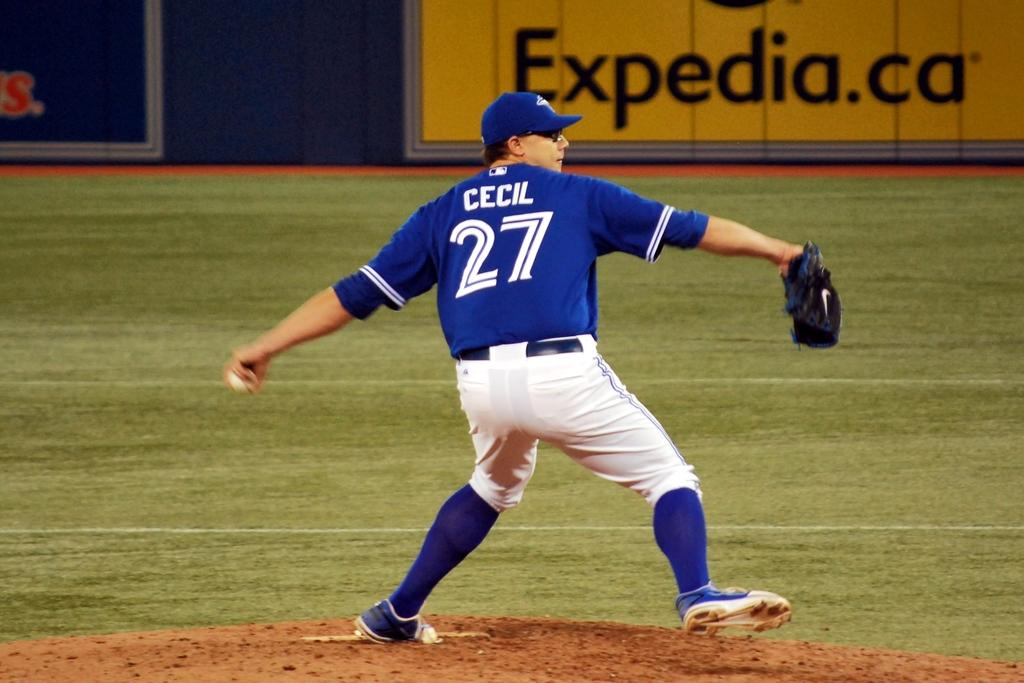<image>
Offer a succinct explanation of the picture presented. A baseball player is wearing a jersey with Cecil on the back. 